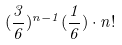Convert formula to latex. <formula><loc_0><loc_0><loc_500><loc_500>( \frac { 3 } { 6 } ) ^ { n - 1 } ( \frac { 1 } { 6 } ) \cdot n !</formula> 